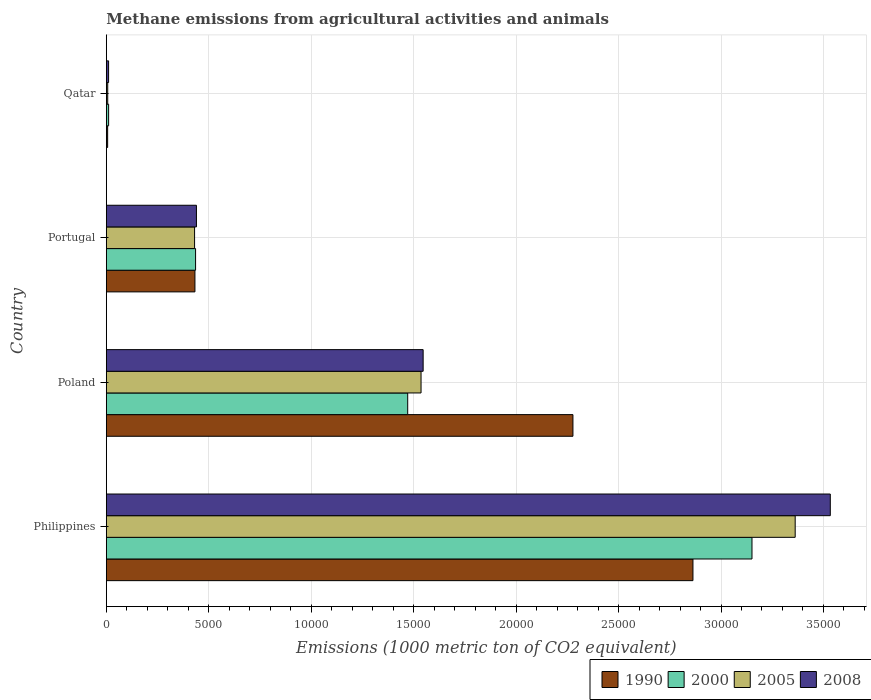How many different coloured bars are there?
Offer a very short reply. 4. In how many cases, is the number of bars for a given country not equal to the number of legend labels?
Offer a terse response. 0. What is the amount of methane emitted in 2008 in Philippines?
Ensure brevity in your answer.  3.53e+04. Across all countries, what is the maximum amount of methane emitted in 2000?
Your answer should be very brief. 3.15e+04. Across all countries, what is the minimum amount of methane emitted in 2005?
Give a very brief answer. 67.4. In which country was the amount of methane emitted in 1990 maximum?
Your answer should be very brief. Philippines. In which country was the amount of methane emitted in 2008 minimum?
Provide a short and direct response. Qatar. What is the total amount of methane emitted in 2005 in the graph?
Provide a short and direct response. 5.34e+04. What is the difference between the amount of methane emitted in 1990 in Poland and that in Qatar?
Offer a very short reply. 2.27e+04. What is the difference between the amount of methane emitted in 2005 in Poland and the amount of methane emitted in 2008 in Philippines?
Provide a short and direct response. -2.00e+04. What is the average amount of methane emitted in 1990 per country?
Your answer should be compact. 1.39e+04. What is the difference between the amount of methane emitted in 2008 and amount of methane emitted in 2005 in Philippines?
Give a very brief answer. 1713.7. What is the ratio of the amount of methane emitted in 2000 in Poland to that in Portugal?
Keep it short and to the point. 3.38. Is the amount of methane emitted in 2008 in Portugal less than that in Qatar?
Provide a succinct answer. No. What is the difference between the highest and the second highest amount of methane emitted in 2005?
Your answer should be very brief. 1.83e+04. What is the difference between the highest and the lowest amount of methane emitted in 2000?
Offer a terse response. 3.14e+04. In how many countries, is the amount of methane emitted in 2008 greater than the average amount of methane emitted in 2008 taken over all countries?
Make the answer very short. 2. Is the sum of the amount of methane emitted in 2008 in Poland and Qatar greater than the maximum amount of methane emitted in 2005 across all countries?
Give a very brief answer. No. What does the 2nd bar from the top in Poland represents?
Provide a succinct answer. 2005. What does the 2nd bar from the bottom in Philippines represents?
Keep it short and to the point. 2000. Is it the case that in every country, the sum of the amount of methane emitted in 2005 and amount of methane emitted in 2000 is greater than the amount of methane emitted in 2008?
Offer a very short reply. Yes. How many bars are there?
Keep it short and to the point. 16. Are the values on the major ticks of X-axis written in scientific E-notation?
Ensure brevity in your answer.  No. Does the graph contain grids?
Provide a succinct answer. Yes. Where does the legend appear in the graph?
Offer a terse response. Bottom right. How are the legend labels stacked?
Offer a very short reply. Horizontal. What is the title of the graph?
Give a very brief answer. Methane emissions from agricultural activities and animals. Does "1981" appear as one of the legend labels in the graph?
Offer a very short reply. No. What is the label or title of the X-axis?
Keep it short and to the point. Emissions (1000 metric ton of CO2 equivalent). What is the Emissions (1000 metric ton of CO2 equivalent) of 1990 in Philippines?
Your answer should be very brief. 2.86e+04. What is the Emissions (1000 metric ton of CO2 equivalent) in 2000 in Philippines?
Your answer should be compact. 3.15e+04. What is the Emissions (1000 metric ton of CO2 equivalent) in 2005 in Philippines?
Provide a short and direct response. 3.36e+04. What is the Emissions (1000 metric ton of CO2 equivalent) of 2008 in Philippines?
Your answer should be very brief. 3.53e+04. What is the Emissions (1000 metric ton of CO2 equivalent) in 1990 in Poland?
Offer a very short reply. 2.28e+04. What is the Emissions (1000 metric ton of CO2 equivalent) of 2000 in Poland?
Offer a terse response. 1.47e+04. What is the Emissions (1000 metric ton of CO2 equivalent) of 2005 in Poland?
Your answer should be compact. 1.54e+04. What is the Emissions (1000 metric ton of CO2 equivalent) of 2008 in Poland?
Offer a very short reply. 1.55e+04. What is the Emissions (1000 metric ton of CO2 equivalent) of 1990 in Portugal?
Provide a succinct answer. 4324.1. What is the Emissions (1000 metric ton of CO2 equivalent) of 2000 in Portugal?
Provide a short and direct response. 4355.4. What is the Emissions (1000 metric ton of CO2 equivalent) in 2005 in Portugal?
Offer a very short reply. 4307.2. What is the Emissions (1000 metric ton of CO2 equivalent) in 2008 in Portugal?
Offer a terse response. 4397.6. What is the Emissions (1000 metric ton of CO2 equivalent) of 1990 in Qatar?
Your response must be concise. 63.8. What is the Emissions (1000 metric ton of CO2 equivalent) of 2000 in Qatar?
Your answer should be compact. 111.5. What is the Emissions (1000 metric ton of CO2 equivalent) of 2005 in Qatar?
Provide a succinct answer. 67.4. What is the Emissions (1000 metric ton of CO2 equivalent) of 2008 in Qatar?
Keep it short and to the point. 110. Across all countries, what is the maximum Emissions (1000 metric ton of CO2 equivalent) in 1990?
Your answer should be compact. 2.86e+04. Across all countries, what is the maximum Emissions (1000 metric ton of CO2 equivalent) of 2000?
Your answer should be very brief. 3.15e+04. Across all countries, what is the maximum Emissions (1000 metric ton of CO2 equivalent) of 2005?
Provide a succinct answer. 3.36e+04. Across all countries, what is the maximum Emissions (1000 metric ton of CO2 equivalent) of 2008?
Your answer should be compact. 3.53e+04. Across all countries, what is the minimum Emissions (1000 metric ton of CO2 equivalent) in 1990?
Your response must be concise. 63.8. Across all countries, what is the minimum Emissions (1000 metric ton of CO2 equivalent) in 2000?
Your response must be concise. 111.5. Across all countries, what is the minimum Emissions (1000 metric ton of CO2 equivalent) of 2005?
Keep it short and to the point. 67.4. Across all countries, what is the minimum Emissions (1000 metric ton of CO2 equivalent) in 2008?
Provide a short and direct response. 110. What is the total Emissions (1000 metric ton of CO2 equivalent) of 1990 in the graph?
Give a very brief answer. 5.58e+04. What is the total Emissions (1000 metric ton of CO2 equivalent) in 2000 in the graph?
Your response must be concise. 5.07e+04. What is the total Emissions (1000 metric ton of CO2 equivalent) of 2005 in the graph?
Your response must be concise. 5.34e+04. What is the total Emissions (1000 metric ton of CO2 equivalent) in 2008 in the graph?
Give a very brief answer. 5.53e+04. What is the difference between the Emissions (1000 metric ton of CO2 equivalent) in 1990 in Philippines and that in Poland?
Your answer should be compact. 5857.1. What is the difference between the Emissions (1000 metric ton of CO2 equivalent) of 2000 in Philippines and that in Poland?
Offer a very short reply. 1.68e+04. What is the difference between the Emissions (1000 metric ton of CO2 equivalent) in 2005 in Philippines and that in Poland?
Ensure brevity in your answer.  1.83e+04. What is the difference between the Emissions (1000 metric ton of CO2 equivalent) of 2008 in Philippines and that in Poland?
Offer a terse response. 1.99e+04. What is the difference between the Emissions (1000 metric ton of CO2 equivalent) in 1990 in Philippines and that in Portugal?
Your answer should be very brief. 2.43e+04. What is the difference between the Emissions (1000 metric ton of CO2 equivalent) in 2000 in Philippines and that in Portugal?
Keep it short and to the point. 2.72e+04. What is the difference between the Emissions (1000 metric ton of CO2 equivalent) in 2005 in Philippines and that in Portugal?
Provide a succinct answer. 2.93e+04. What is the difference between the Emissions (1000 metric ton of CO2 equivalent) of 2008 in Philippines and that in Portugal?
Keep it short and to the point. 3.09e+04. What is the difference between the Emissions (1000 metric ton of CO2 equivalent) of 1990 in Philippines and that in Qatar?
Make the answer very short. 2.86e+04. What is the difference between the Emissions (1000 metric ton of CO2 equivalent) in 2000 in Philippines and that in Qatar?
Your response must be concise. 3.14e+04. What is the difference between the Emissions (1000 metric ton of CO2 equivalent) in 2005 in Philippines and that in Qatar?
Ensure brevity in your answer.  3.36e+04. What is the difference between the Emissions (1000 metric ton of CO2 equivalent) in 2008 in Philippines and that in Qatar?
Your answer should be very brief. 3.52e+04. What is the difference between the Emissions (1000 metric ton of CO2 equivalent) in 1990 in Poland and that in Portugal?
Provide a succinct answer. 1.84e+04. What is the difference between the Emissions (1000 metric ton of CO2 equivalent) of 2000 in Poland and that in Portugal?
Your answer should be very brief. 1.04e+04. What is the difference between the Emissions (1000 metric ton of CO2 equivalent) in 2005 in Poland and that in Portugal?
Give a very brief answer. 1.11e+04. What is the difference between the Emissions (1000 metric ton of CO2 equivalent) of 2008 in Poland and that in Portugal?
Provide a succinct answer. 1.11e+04. What is the difference between the Emissions (1000 metric ton of CO2 equivalent) of 1990 in Poland and that in Qatar?
Offer a terse response. 2.27e+04. What is the difference between the Emissions (1000 metric ton of CO2 equivalent) of 2000 in Poland and that in Qatar?
Keep it short and to the point. 1.46e+04. What is the difference between the Emissions (1000 metric ton of CO2 equivalent) in 2005 in Poland and that in Qatar?
Make the answer very short. 1.53e+04. What is the difference between the Emissions (1000 metric ton of CO2 equivalent) of 2008 in Poland and that in Qatar?
Your response must be concise. 1.54e+04. What is the difference between the Emissions (1000 metric ton of CO2 equivalent) of 1990 in Portugal and that in Qatar?
Your response must be concise. 4260.3. What is the difference between the Emissions (1000 metric ton of CO2 equivalent) of 2000 in Portugal and that in Qatar?
Your response must be concise. 4243.9. What is the difference between the Emissions (1000 metric ton of CO2 equivalent) of 2005 in Portugal and that in Qatar?
Make the answer very short. 4239.8. What is the difference between the Emissions (1000 metric ton of CO2 equivalent) of 2008 in Portugal and that in Qatar?
Your answer should be very brief. 4287.6. What is the difference between the Emissions (1000 metric ton of CO2 equivalent) of 1990 in Philippines and the Emissions (1000 metric ton of CO2 equivalent) of 2000 in Poland?
Your answer should be very brief. 1.39e+04. What is the difference between the Emissions (1000 metric ton of CO2 equivalent) in 1990 in Philippines and the Emissions (1000 metric ton of CO2 equivalent) in 2005 in Poland?
Your answer should be very brief. 1.33e+04. What is the difference between the Emissions (1000 metric ton of CO2 equivalent) of 1990 in Philippines and the Emissions (1000 metric ton of CO2 equivalent) of 2008 in Poland?
Your answer should be very brief. 1.32e+04. What is the difference between the Emissions (1000 metric ton of CO2 equivalent) of 2000 in Philippines and the Emissions (1000 metric ton of CO2 equivalent) of 2005 in Poland?
Your response must be concise. 1.62e+04. What is the difference between the Emissions (1000 metric ton of CO2 equivalent) of 2000 in Philippines and the Emissions (1000 metric ton of CO2 equivalent) of 2008 in Poland?
Make the answer very short. 1.60e+04. What is the difference between the Emissions (1000 metric ton of CO2 equivalent) in 2005 in Philippines and the Emissions (1000 metric ton of CO2 equivalent) in 2008 in Poland?
Your answer should be compact. 1.82e+04. What is the difference between the Emissions (1000 metric ton of CO2 equivalent) of 1990 in Philippines and the Emissions (1000 metric ton of CO2 equivalent) of 2000 in Portugal?
Ensure brevity in your answer.  2.43e+04. What is the difference between the Emissions (1000 metric ton of CO2 equivalent) in 1990 in Philippines and the Emissions (1000 metric ton of CO2 equivalent) in 2005 in Portugal?
Offer a terse response. 2.43e+04. What is the difference between the Emissions (1000 metric ton of CO2 equivalent) of 1990 in Philippines and the Emissions (1000 metric ton of CO2 equivalent) of 2008 in Portugal?
Ensure brevity in your answer.  2.42e+04. What is the difference between the Emissions (1000 metric ton of CO2 equivalent) of 2000 in Philippines and the Emissions (1000 metric ton of CO2 equivalent) of 2005 in Portugal?
Keep it short and to the point. 2.72e+04. What is the difference between the Emissions (1000 metric ton of CO2 equivalent) of 2000 in Philippines and the Emissions (1000 metric ton of CO2 equivalent) of 2008 in Portugal?
Your response must be concise. 2.71e+04. What is the difference between the Emissions (1000 metric ton of CO2 equivalent) in 2005 in Philippines and the Emissions (1000 metric ton of CO2 equivalent) in 2008 in Portugal?
Provide a succinct answer. 2.92e+04. What is the difference between the Emissions (1000 metric ton of CO2 equivalent) of 1990 in Philippines and the Emissions (1000 metric ton of CO2 equivalent) of 2000 in Qatar?
Your response must be concise. 2.85e+04. What is the difference between the Emissions (1000 metric ton of CO2 equivalent) in 1990 in Philippines and the Emissions (1000 metric ton of CO2 equivalent) in 2005 in Qatar?
Ensure brevity in your answer.  2.86e+04. What is the difference between the Emissions (1000 metric ton of CO2 equivalent) in 1990 in Philippines and the Emissions (1000 metric ton of CO2 equivalent) in 2008 in Qatar?
Your response must be concise. 2.85e+04. What is the difference between the Emissions (1000 metric ton of CO2 equivalent) of 2000 in Philippines and the Emissions (1000 metric ton of CO2 equivalent) of 2005 in Qatar?
Keep it short and to the point. 3.14e+04. What is the difference between the Emissions (1000 metric ton of CO2 equivalent) in 2000 in Philippines and the Emissions (1000 metric ton of CO2 equivalent) in 2008 in Qatar?
Provide a short and direct response. 3.14e+04. What is the difference between the Emissions (1000 metric ton of CO2 equivalent) in 2005 in Philippines and the Emissions (1000 metric ton of CO2 equivalent) in 2008 in Qatar?
Provide a short and direct response. 3.35e+04. What is the difference between the Emissions (1000 metric ton of CO2 equivalent) in 1990 in Poland and the Emissions (1000 metric ton of CO2 equivalent) in 2000 in Portugal?
Provide a succinct answer. 1.84e+04. What is the difference between the Emissions (1000 metric ton of CO2 equivalent) of 1990 in Poland and the Emissions (1000 metric ton of CO2 equivalent) of 2005 in Portugal?
Your answer should be very brief. 1.85e+04. What is the difference between the Emissions (1000 metric ton of CO2 equivalent) of 1990 in Poland and the Emissions (1000 metric ton of CO2 equivalent) of 2008 in Portugal?
Your answer should be compact. 1.84e+04. What is the difference between the Emissions (1000 metric ton of CO2 equivalent) in 2000 in Poland and the Emissions (1000 metric ton of CO2 equivalent) in 2005 in Portugal?
Provide a short and direct response. 1.04e+04. What is the difference between the Emissions (1000 metric ton of CO2 equivalent) of 2000 in Poland and the Emissions (1000 metric ton of CO2 equivalent) of 2008 in Portugal?
Your response must be concise. 1.03e+04. What is the difference between the Emissions (1000 metric ton of CO2 equivalent) in 2005 in Poland and the Emissions (1000 metric ton of CO2 equivalent) in 2008 in Portugal?
Offer a terse response. 1.10e+04. What is the difference between the Emissions (1000 metric ton of CO2 equivalent) of 1990 in Poland and the Emissions (1000 metric ton of CO2 equivalent) of 2000 in Qatar?
Provide a succinct answer. 2.27e+04. What is the difference between the Emissions (1000 metric ton of CO2 equivalent) in 1990 in Poland and the Emissions (1000 metric ton of CO2 equivalent) in 2005 in Qatar?
Your answer should be compact. 2.27e+04. What is the difference between the Emissions (1000 metric ton of CO2 equivalent) in 1990 in Poland and the Emissions (1000 metric ton of CO2 equivalent) in 2008 in Qatar?
Your answer should be compact. 2.27e+04. What is the difference between the Emissions (1000 metric ton of CO2 equivalent) in 2000 in Poland and the Emissions (1000 metric ton of CO2 equivalent) in 2005 in Qatar?
Give a very brief answer. 1.46e+04. What is the difference between the Emissions (1000 metric ton of CO2 equivalent) of 2000 in Poland and the Emissions (1000 metric ton of CO2 equivalent) of 2008 in Qatar?
Provide a short and direct response. 1.46e+04. What is the difference between the Emissions (1000 metric ton of CO2 equivalent) of 2005 in Poland and the Emissions (1000 metric ton of CO2 equivalent) of 2008 in Qatar?
Your answer should be compact. 1.52e+04. What is the difference between the Emissions (1000 metric ton of CO2 equivalent) in 1990 in Portugal and the Emissions (1000 metric ton of CO2 equivalent) in 2000 in Qatar?
Your response must be concise. 4212.6. What is the difference between the Emissions (1000 metric ton of CO2 equivalent) in 1990 in Portugal and the Emissions (1000 metric ton of CO2 equivalent) in 2005 in Qatar?
Offer a very short reply. 4256.7. What is the difference between the Emissions (1000 metric ton of CO2 equivalent) in 1990 in Portugal and the Emissions (1000 metric ton of CO2 equivalent) in 2008 in Qatar?
Provide a succinct answer. 4214.1. What is the difference between the Emissions (1000 metric ton of CO2 equivalent) of 2000 in Portugal and the Emissions (1000 metric ton of CO2 equivalent) of 2005 in Qatar?
Your response must be concise. 4288. What is the difference between the Emissions (1000 metric ton of CO2 equivalent) in 2000 in Portugal and the Emissions (1000 metric ton of CO2 equivalent) in 2008 in Qatar?
Make the answer very short. 4245.4. What is the difference between the Emissions (1000 metric ton of CO2 equivalent) of 2005 in Portugal and the Emissions (1000 metric ton of CO2 equivalent) of 2008 in Qatar?
Offer a terse response. 4197.2. What is the average Emissions (1000 metric ton of CO2 equivalent) in 1990 per country?
Your answer should be compact. 1.39e+04. What is the average Emissions (1000 metric ton of CO2 equivalent) in 2000 per country?
Offer a terse response. 1.27e+04. What is the average Emissions (1000 metric ton of CO2 equivalent) of 2005 per country?
Keep it short and to the point. 1.33e+04. What is the average Emissions (1000 metric ton of CO2 equivalent) in 2008 per country?
Your answer should be very brief. 1.38e+04. What is the difference between the Emissions (1000 metric ton of CO2 equivalent) of 1990 and Emissions (1000 metric ton of CO2 equivalent) of 2000 in Philippines?
Offer a terse response. -2881.3. What is the difference between the Emissions (1000 metric ton of CO2 equivalent) in 1990 and Emissions (1000 metric ton of CO2 equivalent) in 2005 in Philippines?
Your answer should be very brief. -4989.5. What is the difference between the Emissions (1000 metric ton of CO2 equivalent) in 1990 and Emissions (1000 metric ton of CO2 equivalent) in 2008 in Philippines?
Offer a very short reply. -6703.2. What is the difference between the Emissions (1000 metric ton of CO2 equivalent) of 2000 and Emissions (1000 metric ton of CO2 equivalent) of 2005 in Philippines?
Make the answer very short. -2108.2. What is the difference between the Emissions (1000 metric ton of CO2 equivalent) of 2000 and Emissions (1000 metric ton of CO2 equivalent) of 2008 in Philippines?
Ensure brevity in your answer.  -3821.9. What is the difference between the Emissions (1000 metric ton of CO2 equivalent) of 2005 and Emissions (1000 metric ton of CO2 equivalent) of 2008 in Philippines?
Provide a succinct answer. -1713.7. What is the difference between the Emissions (1000 metric ton of CO2 equivalent) in 1990 and Emissions (1000 metric ton of CO2 equivalent) in 2000 in Poland?
Offer a terse response. 8065. What is the difference between the Emissions (1000 metric ton of CO2 equivalent) in 1990 and Emissions (1000 metric ton of CO2 equivalent) in 2005 in Poland?
Your answer should be very brief. 7413.7. What is the difference between the Emissions (1000 metric ton of CO2 equivalent) in 1990 and Emissions (1000 metric ton of CO2 equivalent) in 2008 in Poland?
Offer a terse response. 7311.1. What is the difference between the Emissions (1000 metric ton of CO2 equivalent) of 2000 and Emissions (1000 metric ton of CO2 equivalent) of 2005 in Poland?
Keep it short and to the point. -651.3. What is the difference between the Emissions (1000 metric ton of CO2 equivalent) in 2000 and Emissions (1000 metric ton of CO2 equivalent) in 2008 in Poland?
Your response must be concise. -753.9. What is the difference between the Emissions (1000 metric ton of CO2 equivalent) of 2005 and Emissions (1000 metric ton of CO2 equivalent) of 2008 in Poland?
Provide a short and direct response. -102.6. What is the difference between the Emissions (1000 metric ton of CO2 equivalent) in 1990 and Emissions (1000 metric ton of CO2 equivalent) in 2000 in Portugal?
Keep it short and to the point. -31.3. What is the difference between the Emissions (1000 metric ton of CO2 equivalent) in 1990 and Emissions (1000 metric ton of CO2 equivalent) in 2005 in Portugal?
Make the answer very short. 16.9. What is the difference between the Emissions (1000 metric ton of CO2 equivalent) in 1990 and Emissions (1000 metric ton of CO2 equivalent) in 2008 in Portugal?
Ensure brevity in your answer.  -73.5. What is the difference between the Emissions (1000 metric ton of CO2 equivalent) in 2000 and Emissions (1000 metric ton of CO2 equivalent) in 2005 in Portugal?
Offer a very short reply. 48.2. What is the difference between the Emissions (1000 metric ton of CO2 equivalent) in 2000 and Emissions (1000 metric ton of CO2 equivalent) in 2008 in Portugal?
Your response must be concise. -42.2. What is the difference between the Emissions (1000 metric ton of CO2 equivalent) of 2005 and Emissions (1000 metric ton of CO2 equivalent) of 2008 in Portugal?
Make the answer very short. -90.4. What is the difference between the Emissions (1000 metric ton of CO2 equivalent) in 1990 and Emissions (1000 metric ton of CO2 equivalent) in 2000 in Qatar?
Your answer should be very brief. -47.7. What is the difference between the Emissions (1000 metric ton of CO2 equivalent) of 1990 and Emissions (1000 metric ton of CO2 equivalent) of 2005 in Qatar?
Offer a terse response. -3.6. What is the difference between the Emissions (1000 metric ton of CO2 equivalent) of 1990 and Emissions (1000 metric ton of CO2 equivalent) of 2008 in Qatar?
Offer a terse response. -46.2. What is the difference between the Emissions (1000 metric ton of CO2 equivalent) in 2000 and Emissions (1000 metric ton of CO2 equivalent) in 2005 in Qatar?
Your answer should be compact. 44.1. What is the difference between the Emissions (1000 metric ton of CO2 equivalent) of 2005 and Emissions (1000 metric ton of CO2 equivalent) of 2008 in Qatar?
Provide a succinct answer. -42.6. What is the ratio of the Emissions (1000 metric ton of CO2 equivalent) of 1990 in Philippines to that in Poland?
Your answer should be very brief. 1.26. What is the ratio of the Emissions (1000 metric ton of CO2 equivalent) of 2000 in Philippines to that in Poland?
Give a very brief answer. 2.14. What is the ratio of the Emissions (1000 metric ton of CO2 equivalent) of 2005 in Philippines to that in Poland?
Make the answer very short. 2.19. What is the ratio of the Emissions (1000 metric ton of CO2 equivalent) of 2008 in Philippines to that in Poland?
Your answer should be compact. 2.29. What is the ratio of the Emissions (1000 metric ton of CO2 equivalent) in 1990 in Philippines to that in Portugal?
Your answer should be very brief. 6.62. What is the ratio of the Emissions (1000 metric ton of CO2 equivalent) of 2000 in Philippines to that in Portugal?
Provide a succinct answer. 7.24. What is the ratio of the Emissions (1000 metric ton of CO2 equivalent) of 2005 in Philippines to that in Portugal?
Give a very brief answer. 7.81. What is the ratio of the Emissions (1000 metric ton of CO2 equivalent) in 2008 in Philippines to that in Portugal?
Ensure brevity in your answer.  8.03. What is the ratio of the Emissions (1000 metric ton of CO2 equivalent) of 1990 in Philippines to that in Qatar?
Offer a terse response. 448.76. What is the ratio of the Emissions (1000 metric ton of CO2 equivalent) of 2000 in Philippines to that in Qatar?
Offer a terse response. 282.62. What is the ratio of the Emissions (1000 metric ton of CO2 equivalent) in 2005 in Philippines to that in Qatar?
Provide a short and direct response. 498.81. What is the ratio of the Emissions (1000 metric ton of CO2 equivalent) in 2008 in Philippines to that in Qatar?
Make the answer very short. 321.22. What is the ratio of the Emissions (1000 metric ton of CO2 equivalent) of 1990 in Poland to that in Portugal?
Provide a short and direct response. 5.27. What is the ratio of the Emissions (1000 metric ton of CO2 equivalent) of 2000 in Poland to that in Portugal?
Offer a terse response. 3.38. What is the ratio of the Emissions (1000 metric ton of CO2 equivalent) of 2005 in Poland to that in Portugal?
Your answer should be compact. 3.57. What is the ratio of the Emissions (1000 metric ton of CO2 equivalent) in 2008 in Poland to that in Portugal?
Make the answer very short. 3.52. What is the ratio of the Emissions (1000 metric ton of CO2 equivalent) in 1990 in Poland to that in Qatar?
Your answer should be compact. 356.95. What is the ratio of the Emissions (1000 metric ton of CO2 equivalent) in 2000 in Poland to that in Qatar?
Give a very brief answer. 131.91. What is the ratio of the Emissions (1000 metric ton of CO2 equivalent) in 2005 in Poland to that in Qatar?
Offer a terse response. 227.89. What is the ratio of the Emissions (1000 metric ton of CO2 equivalent) of 2008 in Poland to that in Qatar?
Your answer should be compact. 140.57. What is the ratio of the Emissions (1000 metric ton of CO2 equivalent) in 1990 in Portugal to that in Qatar?
Provide a short and direct response. 67.78. What is the ratio of the Emissions (1000 metric ton of CO2 equivalent) in 2000 in Portugal to that in Qatar?
Provide a short and direct response. 39.06. What is the ratio of the Emissions (1000 metric ton of CO2 equivalent) in 2005 in Portugal to that in Qatar?
Make the answer very short. 63.91. What is the ratio of the Emissions (1000 metric ton of CO2 equivalent) in 2008 in Portugal to that in Qatar?
Your answer should be compact. 39.98. What is the difference between the highest and the second highest Emissions (1000 metric ton of CO2 equivalent) in 1990?
Your answer should be compact. 5857.1. What is the difference between the highest and the second highest Emissions (1000 metric ton of CO2 equivalent) of 2000?
Provide a short and direct response. 1.68e+04. What is the difference between the highest and the second highest Emissions (1000 metric ton of CO2 equivalent) in 2005?
Provide a succinct answer. 1.83e+04. What is the difference between the highest and the second highest Emissions (1000 metric ton of CO2 equivalent) in 2008?
Offer a terse response. 1.99e+04. What is the difference between the highest and the lowest Emissions (1000 metric ton of CO2 equivalent) of 1990?
Provide a short and direct response. 2.86e+04. What is the difference between the highest and the lowest Emissions (1000 metric ton of CO2 equivalent) in 2000?
Ensure brevity in your answer.  3.14e+04. What is the difference between the highest and the lowest Emissions (1000 metric ton of CO2 equivalent) of 2005?
Offer a terse response. 3.36e+04. What is the difference between the highest and the lowest Emissions (1000 metric ton of CO2 equivalent) of 2008?
Provide a succinct answer. 3.52e+04. 